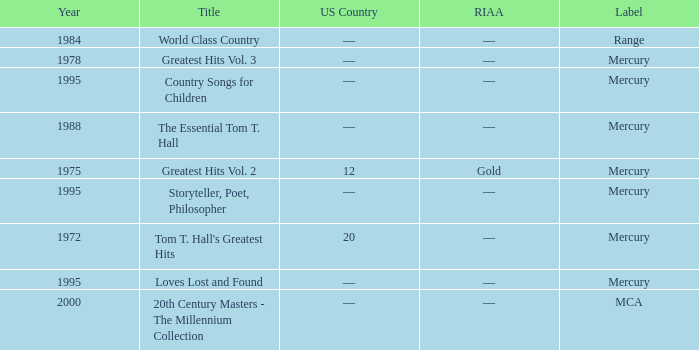Help me parse the entirety of this table. {'header': ['Year', 'Title', 'US Country', 'RIAA', 'Label'], 'rows': [['1984', 'World Class Country', '—', '—', 'Range'], ['1978', 'Greatest Hits Vol. 3', '—', '—', 'Mercury'], ['1995', 'Country Songs for Children', '—', '—', 'Mercury'], ['1988', 'The Essential Tom T. Hall', '—', '—', 'Mercury'], ['1975', 'Greatest Hits Vol. 2', '12', 'Gold', 'Mercury'], ['1995', 'Storyteller, Poet, Philosopher', '—', '—', 'Mercury'], ['1972', "Tom T. Hall's Greatest Hits", '20', '—', 'Mercury'], ['1995', 'Loves Lost and Found', '—', '—', 'Mercury'], ['2000', '20th Century Masters - The Millennium Collection', '—', '—', 'MCA']]} What label had the album after 1978? Range, Mercury, Mercury, Mercury, Mercury, MCA. 